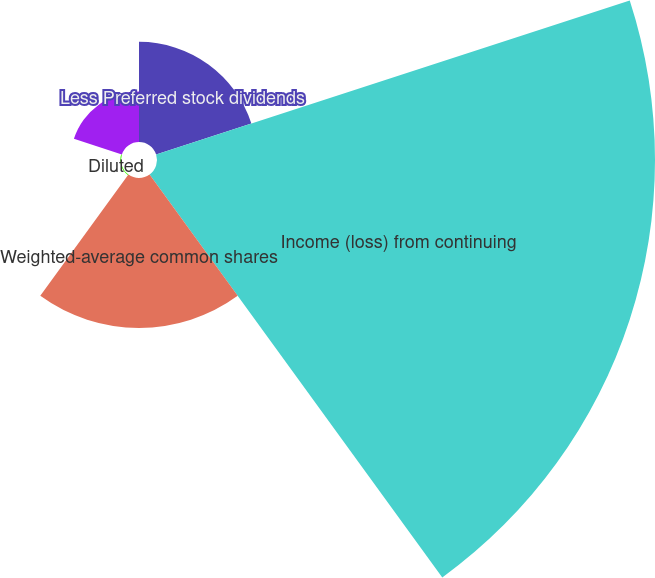Convert chart. <chart><loc_0><loc_0><loc_500><loc_500><pie_chart><fcel>Less Preferred stock dividends<fcel>Income (loss) from continuing<fcel>Weighted-average common shares<fcel>Diluted<fcel>Basic<nl><fcel>12.53%<fcel>62.31%<fcel>18.76%<fcel>0.09%<fcel>6.31%<nl></chart> 